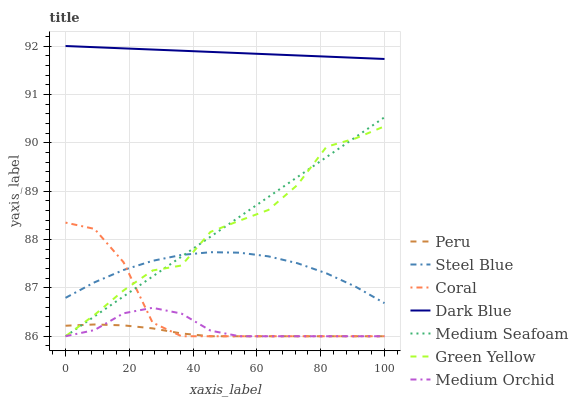Does Peru have the minimum area under the curve?
Answer yes or no. Yes. Does Dark Blue have the maximum area under the curve?
Answer yes or no. Yes. Does Medium Orchid have the minimum area under the curve?
Answer yes or no. No. Does Medium Orchid have the maximum area under the curve?
Answer yes or no. No. Is Medium Seafoam the smoothest?
Answer yes or no. Yes. Is Green Yellow the roughest?
Answer yes or no. Yes. Is Medium Orchid the smoothest?
Answer yes or no. No. Is Medium Orchid the roughest?
Answer yes or no. No. Does Coral have the lowest value?
Answer yes or no. Yes. Does Steel Blue have the lowest value?
Answer yes or no. No. Does Dark Blue have the highest value?
Answer yes or no. Yes. Does Medium Orchid have the highest value?
Answer yes or no. No. Is Green Yellow less than Dark Blue?
Answer yes or no. Yes. Is Dark Blue greater than Green Yellow?
Answer yes or no. Yes. Does Coral intersect Medium Orchid?
Answer yes or no. Yes. Is Coral less than Medium Orchid?
Answer yes or no. No. Is Coral greater than Medium Orchid?
Answer yes or no. No. Does Green Yellow intersect Dark Blue?
Answer yes or no. No. 